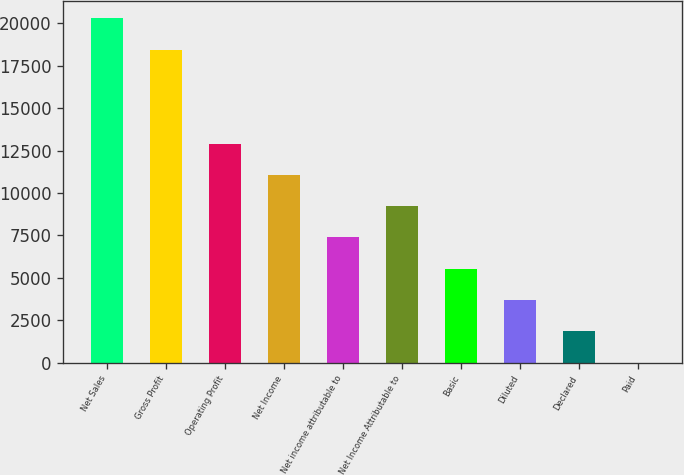<chart> <loc_0><loc_0><loc_500><loc_500><bar_chart><fcel>Net Sales<fcel>Gross Profit<fcel>Operating Profit<fcel>Net Income<fcel>Net income attributable to<fcel>Net Income Attributable to<fcel>Basic<fcel>Diluted<fcel>Declared<fcel>Paid<nl><fcel>20283.8<fcel>18440<fcel>12908.6<fcel>11064.8<fcel>7377.24<fcel>9221.03<fcel>5533.45<fcel>3689.66<fcel>1845.87<fcel>2.08<nl></chart> 